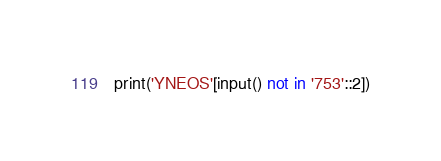<code> <loc_0><loc_0><loc_500><loc_500><_Python_>print('YNEOS'[input() not in '753'::2])</code> 